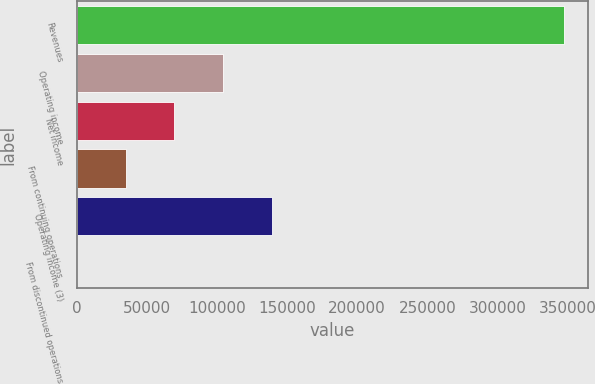<chart> <loc_0><loc_0><loc_500><loc_500><bar_chart><fcel>Revenues<fcel>Operating income<fcel>Net income<fcel>From continuing operations<fcel>Operating income (3)<fcel>From discontinued operations<nl><fcel>347321<fcel>104196<fcel>69464.2<fcel>34732.1<fcel>138928<fcel>0.01<nl></chart> 